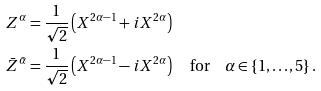<formula> <loc_0><loc_0><loc_500><loc_500>Z ^ { \alpha } & = \frac { 1 } { \sqrt { 2 } } \left ( X ^ { 2 \alpha - 1 } + i X ^ { 2 \alpha } \right ) \\ \bar { Z } ^ { \bar { \alpha } } & = \frac { 1 } { \sqrt { 2 } } \left ( X ^ { 2 \alpha - 1 } - i X ^ { 2 \alpha } \right ) \quad \text {for} \quad \alpha \in \left \{ 1 , \dots , 5 \right \} .</formula> 